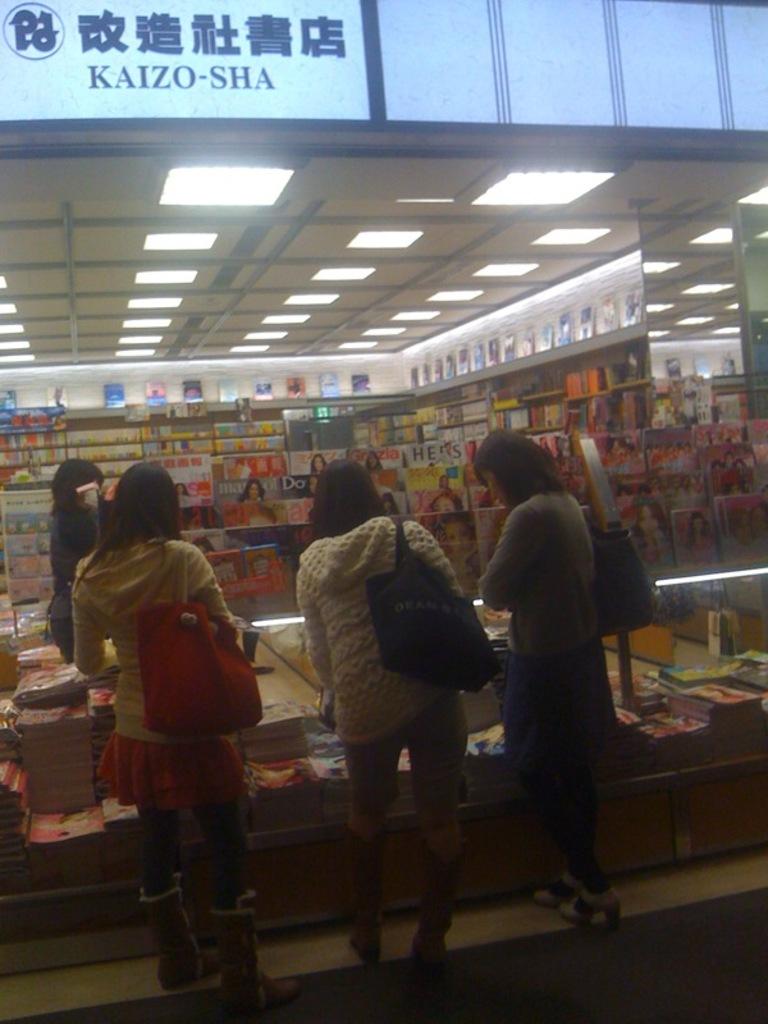What does the sign say?
Ensure brevity in your answer.  Kaizo-sha. What two letters are on the magazine immediately to the left of the girls head in the middle of the picture?
Offer a very short reply. Do. 